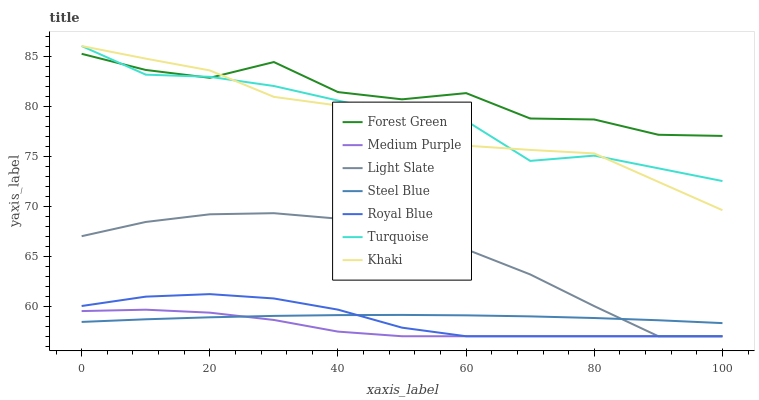Does Medium Purple have the minimum area under the curve?
Answer yes or no. Yes. Does Forest Green have the maximum area under the curve?
Answer yes or no. Yes. Does Khaki have the minimum area under the curve?
Answer yes or no. No. Does Khaki have the maximum area under the curve?
Answer yes or no. No. Is Steel Blue the smoothest?
Answer yes or no. Yes. Is Forest Green the roughest?
Answer yes or no. Yes. Is Khaki the smoothest?
Answer yes or no. No. Is Khaki the roughest?
Answer yes or no. No. Does Khaki have the lowest value?
Answer yes or no. No. Does Khaki have the highest value?
Answer yes or no. Yes. Does Light Slate have the highest value?
Answer yes or no. No. Is Royal Blue less than Khaki?
Answer yes or no. Yes. Is Turquoise greater than Medium Purple?
Answer yes or no. Yes. Does Royal Blue intersect Khaki?
Answer yes or no. No. 